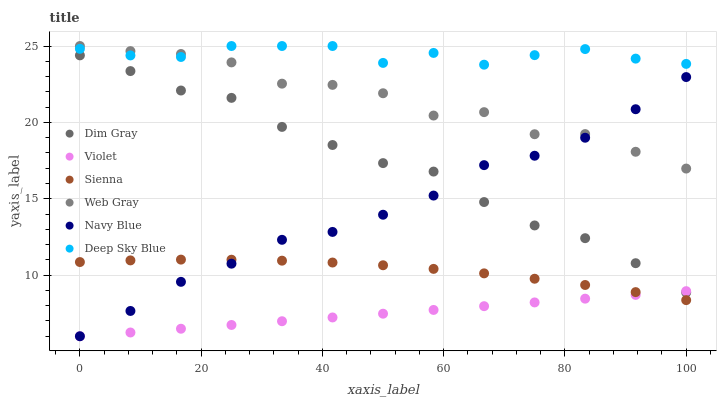Does Violet have the minimum area under the curve?
Answer yes or no. Yes. Does Deep Sky Blue have the maximum area under the curve?
Answer yes or no. Yes. Does Navy Blue have the minimum area under the curve?
Answer yes or no. No. Does Navy Blue have the maximum area under the curve?
Answer yes or no. No. Is Violet the smoothest?
Answer yes or no. Yes. Is Web Gray the roughest?
Answer yes or no. Yes. Is Navy Blue the smoothest?
Answer yes or no. No. Is Navy Blue the roughest?
Answer yes or no. No. Does Navy Blue have the lowest value?
Answer yes or no. Yes. Does Sienna have the lowest value?
Answer yes or no. No. Does Deep Sky Blue have the highest value?
Answer yes or no. Yes. Does Navy Blue have the highest value?
Answer yes or no. No. Is Dim Gray less than Deep Sky Blue?
Answer yes or no. Yes. Is Deep Sky Blue greater than Dim Gray?
Answer yes or no. Yes. Does Navy Blue intersect Violet?
Answer yes or no. Yes. Is Navy Blue less than Violet?
Answer yes or no. No. Is Navy Blue greater than Violet?
Answer yes or no. No. Does Dim Gray intersect Deep Sky Blue?
Answer yes or no. No. 